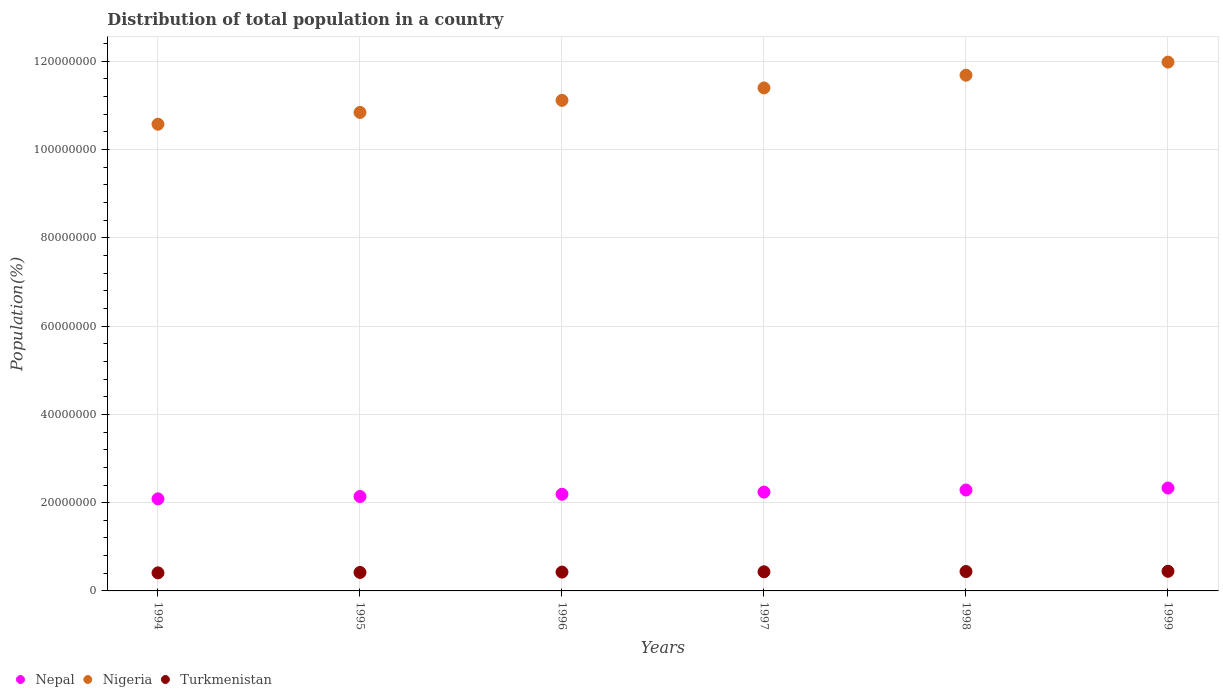How many different coloured dotlines are there?
Provide a short and direct response. 3. Is the number of dotlines equal to the number of legend labels?
Your answer should be very brief. Yes. What is the population of in Nepal in 1994?
Offer a very short reply. 2.09e+07. Across all years, what is the maximum population of in Nigeria?
Provide a succinct answer. 1.20e+08. Across all years, what is the minimum population of in Turkmenistan?
Offer a terse response. 4.10e+06. In which year was the population of in Turkmenistan minimum?
Provide a succinct answer. 1994. What is the total population of in Turkmenistan in the graph?
Offer a very short reply. 2.57e+07. What is the difference between the population of in Nigeria in 1994 and that in 1995?
Make the answer very short. -2.67e+06. What is the difference between the population of in Nigeria in 1994 and the population of in Turkmenistan in 1996?
Offer a very short reply. 1.01e+08. What is the average population of in Turkmenistan per year?
Your answer should be very brief. 4.29e+06. In the year 1995, what is the difference between the population of in Nigeria and population of in Turkmenistan?
Offer a very short reply. 1.04e+08. In how many years, is the population of in Nepal greater than 52000000 %?
Provide a succinct answer. 0. What is the ratio of the population of in Nigeria in 1994 to that in 1995?
Keep it short and to the point. 0.98. Is the population of in Turkmenistan in 1994 less than that in 1995?
Offer a terse response. Yes. What is the difference between the highest and the second highest population of in Nigeria?
Provide a short and direct response. 2.97e+06. What is the difference between the highest and the lowest population of in Nepal?
Your answer should be very brief. 2.46e+06. In how many years, is the population of in Nepal greater than the average population of in Nepal taken over all years?
Keep it short and to the point. 3. Does the population of in Nepal monotonically increase over the years?
Your answer should be very brief. Yes. Is the population of in Turkmenistan strictly greater than the population of in Nepal over the years?
Make the answer very short. No. Is the population of in Nigeria strictly less than the population of in Turkmenistan over the years?
Your answer should be compact. No. How many years are there in the graph?
Your answer should be compact. 6. Does the graph contain any zero values?
Offer a very short reply. No. Where does the legend appear in the graph?
Ensure brevity in your answer.  Bottom left. How many legend labels are there?
Ensure brevity in your answer.  3. How are the legend labels stacked?
Your response must be concise. Horizontal. What is the title of the graph?
Offer a terse response. Distribution of total population in a country. What is the label or title of the Y-axis?
Provide a short and direct response. Population(%). What is the Population(%) in Nepal in 1994?
Provide a succinct answer. 2.09e+07. What is the Population(%) of Nigeria in 1994?
Offer a very short reply. 1.06e+08. What is the Population(%) of Turkmenistan in 1994?
Offer a terse response. 4.10e+06. What is the Population(%) in Nepal in 1995?
Provide a succinct answer. 2.14e+07. What is the Population(%) of Nigeria in 1995?
Provide a short and direct response. 1.08e+08. What is the Population(%) in Turkmenistan in 1995?
Offer a very short reply. 4.19e+06. What is the Population(%) of Nepal in 1996?
Keep it short and to the point. 2.19e+07. What is the Population(%) of Nigeria in 1996?
Offer a very short reply. 1.11e+08. What is the Population(%) of Turkmenistan in 1996?
Offer a terse response. 4.27e+06. What is the Population(%) of Nepal in 1997?
Offer a very short reply. 2.24e+07. What is the Population(%) of Nigeria in 1997?
Provide a short and direct response. 1.14e+08. What is the Population(%) in Turkmenistan in 1997?
Make the answer very short. 4.34e+06. What is the Population(%) of Nepal in 1998?
Offer a terse response. 2.29e+07. What is the Population(%) of Nigeria in 1998?
Your answer should be very brief. 1.17e+08. What is the Population(%) in Turkmenistan in 1998?
Your answer should be compact. 4.40e+06. What is the Population(%) of Nepal in 1999?
Provide a short and direct response. 2.33e+07. What is the Population(%) of Nigeria in 1999?
Your response must be concise. 1.20e+08. What is the Population(%) of Turkmenistan in 1999?
Keep it short and to the point. 4.45e+06. Across all years, what is the maximum Population(%) in Nepal?
Keep it short and to the point. 2.33e+07. Across all years, what is the maximum Population(%) of Nigeria?
Keep it short and to the point. 1.20e+08. Across all years, what is the maximum Population(%) in Turkmenistan?
Give a very brief answer. 4.45e+06. Across all years, what is the minimum Population(%) in Nepal?
Your answer should be very brief. 2.09e+07. Across all years, what is the minimum Population(%) in Nigeria?
Ensure brevity in your answer.  1.06e+08. Across all years, what is the minimum Population(%) of Turkmenistan?
Provide a short and direct response. 4.10e+06. What is the total Population(%) of Nepal in the graph?
Give a very brief answer. 1.33e+08. What is the total Population(%) in Nigeria in the graph?
Your response must be concise. 6.76e+08. What is the total Population(%) of Turkmenistan in the graph?
Ensure brevity in your answer.  2.57e+07. What is the difference between the Population(%) in Nepal in 1994 and that in 1995?
Provide a short and direct response. -5.31e+05. What is the difference between the Population(%) of Nigeria in 1994 and that in 1995?
Make the answer very short. -2.67e+06. What is the difference between the Population(%) in Turkmenistan in 1994 and that in 1995?
Your answer should be very brief. -9.25e+04. What is the difference between the Population(%) in Nepal in 1994 and that in 1996?
Your answer should be compact. -1.04e+06. What is the difference between the Population(%) of Nigeria in 1994 and that in 1996?
Offer a terse response. -5.41e+06. What is the difference between the Population(%) of Turkmenistan in 1994 and that in 1996?
Make the answer very short. -1.72e+05. What is the difference between the Population(%) of Nepal in 1994 and that in 1997?
Ensure brevity in your answer.  -1.54e+06. What is the difference between the Population(%) in Nigeria in 1994 and that in 1997?
Your answer should be very brief. -8.22e+06. What is the difference between the Population(%) in Turkmenistan in 1994 and that in 1997?
Ensure brevity in your answer.  -2.40e+05. What is the difference between the Population(%) of Nepal in 1994 and that in 1998?
Make the answer very short. -2.01e+06. What is the difference between the Population(%) in Nigeria in 1994 and that in 1998?
Your response must be concise. -1.11e+07. What is the difference between the Population(%) of Turkmenistan in 1994 and that in 1998?
Provide a short and direct response. -3.00e+05. What is the difference between the Population(%) of Nepal in 1994 and that in 1999?
Offer a terse response. -2.46e+06. What is the difference between the Population(%) of Nigeria in 1994 and that in 1999?
Your response must be concise. -1.41e+07. What is the difference between the Population(%) of Turkmenistan in 1994 and that in 1999?
Your response must be concise. -3.54e+05. What is the difference between the Population(%) in Nepal in 1995 and that in 1996?
Your response must be concise. -5.12e+05. What is the difference between the Population(%) of Nigeria in 1995 and that in 1996?
Give a very brief answer. -2.74e+06. What is the difference between the Population(%) of Turkmenistan in 1995 and that in 1996?
Offer a terse response. -7.97e+04. What is the difference between the Population(%) in Nepal in 1995 and that in 1997?
Ensure brevity in your answer.  -1.00e+06. What is the difference between the Population(%) in Nigeria in 1995 and that in 1997?
Offer a terse response. -5.55e+06. What is the difference between the Population(%) of Turkmenistan in 1995 and that in 1997?
Offer a very short reply. -1.48e+05. What is the difference between the Population(%) of Nepal in 1995 and that in 1998?
Ensure brevity in your answer.  -1.48e+06. What is the difference between the Population(%) in Nigeria in 1995 and that in 1998?
Your answer should be very brief. -8.44e+06. What is the difference between the Population(%) of Turkmenistan in 1995 and that in 1998?
Give a very brief answer. -2.07e+05. What is the difference between the Population(%) in Nepal in 1995 and that in 1999?
Offer a terse response. -1.92e+06. What is the difference between the Population(%) in Nigeria in 1995 and that in 1999?
Give a very brief answer. -1.14e+07. What is the difference between the Population(%) of Turkmenistan in 1995 and that in 1999?
Keep it short and to the point. -2.61e+05. What is the difference between the Population(%) in Nepal in 1996 and that in 1997?
Give a very brief answer. -4.93e+05. What is the difference between the Population(%) in Nigeria in 1996 and that in 1997?
Give a very brief answer. -2.81e+06. What is the difference between the Population(%) of Turkmenistan in 1996 and that in 1997?
Offer a terse response. -6.83e+04. What is the difference between the Population(%) of Nepal in 1996 and that in 1998?
Offer a very short reply. -9.64e+05. What is the difference between the Population(%) in Nigeria in 1996 and that in 1998?
Keep it short and to the point. -5.70e+06. What is the difference between the Population(%) of Turkmenistan in 1996 and that in 1998?
Offer a terse response. -1.28e+05. What is the difference between the Population(%) in Nepal in 1996 and that in 1999?
Your answer should be compact. -1.41e+06. What is the difference between the Population(%) in Nigeria in 1996 and that in 1999?
Make the answer very short. -8.66e+06. What is the difference between the Population(%) of Turkmenistan in 1996 and that in 1999?
Provide a short and direct response. -1.82e+05. What is the difference between the Population(%) of Nepal in 1997 and that in 1998?
Give a very brief answer. -4.71e+05. What is the difference between the Population(%) in Nigeria in 1997 and that in 1998?
Your answer should be compact. -2.89e+06. What is the difference between the Population(%) in Turkmenistan in 1997 and that in 1998?
Offer a very short reply. -5.93e+04. What is the difference between the Population(%) in Nepal in 1997 and that in 1999?
Your answer should be very brief. -9.20e+05. What is the difference between the Population(%) of Nigeria in 1997 and that in 1999?
Your answer should be very brief. -5.85e+06. What is the difference between the Population(%) of Turkmenistan in 1997 and that in 1999?
Offer a terse response. -1.13e+05. What is the difference between the Population(%) in Nepal in 1998 and that in 1999?
Give a very brief answer. -4.49e+05. What is the difference between the Population(%) in Nigeria in 1998 and that in 1999?
Make the answer very short. -2.97e+06. What is the difference between the Population(%) of Turkmenistan in 1998 and that in 1999?
Keep it short and to the point. -5.41e+04. What is the difference between the Population(%) of Nepal in 1994 and the Population(%) of Nigeria in 1995?
Offer a terse response. -8.76e+07. What is the difference between the Population(%) of Nepal in 1994 and the Population(%) of Turkmenistan in 1995?
Make the answer very short. 1.67e+07. What is the difference between the Population(%) in Nigeria in 1994 and the Population(%) in Turkmenistan in 1995?
Keep it short and to the point. 1.02e+08. What is the difference between the Population(%) of Nepal in 1994 and the Population(%) of Nigeria in 1996?
Ensure brevity in your answer.  -9.03e+07. What is the difference between the Population(%) in Nepal in 1994 and the Population(%) in Turkmenistan in 1996?
Provide a succinct answer. 1.66e+07. What is the difference between the Population(%) of Nigeria in 1994 and the Population(%) of Turkmenistan in 1996?
Your response must be concise. 1.01e+08. What is the difference between the Population(%) in Nepal in 1994 and the Population(%) in Nigeria in 1997?
Offer a very short reply. -9.31e+07. What is the difference between the Population(%) of Nepal in 1994 and the Population(%) of Turkmenistan in 1997?
Your response must be concise. 1.65e+07. What is the difference between the Population(%) in Nigeria in 1994 and the Population(%) in Turkmenistan in 1997?
Your answer should be very brief. 1.01e+08. What is the difference between the Population(%) in Nepal in 1994 and the Population(%) in Nigeria in 1998?
Your response must be concise. -9.60e+07. What is the difference between the Population(%) of Nepal in 1994 and the Population(%) of Turkmenistan in 1998?
Ensure brevity in your answer.  1.65e+07. What is the difference between the Population(%) in Nigeria in 1994 and the Population(%) in Turkmenistan in 1998?
Ensure brevity in your answer.  1.01e+08. What is the difference between the Population(%) in Nepal in 1994 and the Population(%) in Nigeria in 1999?
Provide a succinct answer. -9.90e+07. What is the difference between the Population(%) of Nepal in 1994 and the Population(%) of Turkmenistan in 1999?
Offer a very short reply. 1.64e+07. What is the difference between the Population(%) of Nigeria in 1994 and the Population(%) of Turkmenistan in 1999?
Provide a succinct answer. 1.01e+08. What is the difference between the Population(%) of Nepal in 1995 and the Population(%) of Nigeria in 1996?
Offer a very short reply. -8.98e+07. What is the difference between the Population(%) of Nepal in 1995 and the Population(%) of Turkmenistan in 1996?
Provide a short and direct response. 1.71e+07. What is the difference between the Population(%) of Nigeria in 1995 and the Population(%) of Turkmenistan in 1996?
Ensure brevity in your answer.  1.04e+08. What is the difference between the Population(%) in Nepal in 1995 and the Population(%) in Nigeria in 1997?
Provide a succinct answer. -9.26e+07. What is the difference between the Population(%) in Nepal in 1995 and the Population(%) in Turkmenistan in 1997?
Provide a short and direct response. 1.71e+07. What is the difference between the Population(%) in Nigeria in 1995 and the Population(%) in Turkmenistan in 1997?
Keep it short and to the point. 1.04e+08. What is the difference between the Population(%) in Nepal in 1995 and the Population(%) in Nigeria in 1998?
Keep it short and to the point. -9.55e+07. What is the difference between the Population(%) of Nepal in 1995 and the Population(%) of Turkmenistan in 1998?
Offer a very short reply. 1.70e+07. What is the difference between the Population(%) in Nigeria in 1995 and the Population(%) in Turkmenistan in 1998?
Make the answer very short. 1.04e+08. What is the difference between the Population(%) of Nepal in 1995 and the Population(%) of Nigeria in 1999?
Give a very brief answer. -9.84e+07. What is the difference between the Population(%) of Nepal in 1995 and the Population(%) of Turkmenistan in 1999?
Your response must be concise. 1.69e+07. What is the difference between the Population(%) in Nigeria in 1995 and the Population(%) in Turkmenistan in 1999?
Make the answer very short. 1.04e+08. What is the difference between the Population(%) of Nepal in 1996 and the Population(%) of Nigeria in 1997?
Your answer should be very brief. -9.21e+07. What is the difference between the Population(%) in Nepal in 1996 and the Population(%) in Turkmenistan in 1997?
Give a very brief answer. 1.76e+07. What is the difference between the Population(%) of Nigeria in 1996 and the Population(%) of Turkmenistan in 1997?
Your response must be concise. 1.07e+08. What is the difference between the Population(%) in Nepal in 1996 and the Population(%) in Nigeria in 1998?
Provide a short and direct response. -9.50e+07. What is the difference between the Population(%) in Nepal in 1996 and the Population(%) in Turkmenistan in 1998?
Your response must be concise. 1.75e+07. What is the difference between the Population(%) in Nigeria in 1996 and the Population(%) in Turkmenistan in 1998?
Provide a succinct answer. 1.07e+08. What is the difference between the Population(%) of Nepal in 1996 and the Population(%) of Nigeria in 1999?
Ensure brevity in your answer.  -9.79e+07. What is the difference between the Population(%) of Nepal in 1996 and the Population(%) of Turkmenistan in 1999?
Provide a succinct answer. 1.75e+07. What is the difference between the Population(%) of Nigeria in 1996 and the Population(%) of Turkmenistan in 1999?
Your answer should be compact. 1.07e+08. What is the difference between the Population(%) of Nepal in 1997 and the Population(%) of Nigeria in 1998?
Offer a terse response. -9.45e+07. What is the difference between the Population(%) in Nepal in 1997 and the Population(%) in Turkmenistan in 1998?
Offer a terse response. 1.80e+07. What is the difference between the Population(%) of Nigeria in 1997 and the Population(%) of Turkmenistan in 1998?
Your answer should be very brief. 1.10e+08. What is the difference between the Population(%) of Nepal in 1997 and the Population(%) of Nigeria in 1999?
Your answer should be very brief. -9.74e+07. What is the difference between the Population(%) of Nepal in 1997 and the Population(%) of Turkmenistan in 1999?
Ensure brevity in your answer.  1.79e+07. What is the difference between the Population(%) in Nigeria in 1997 and the Population(%) in Turkmenistan in 1999?
Give a very brief answer. 1.10e+08. What is the difference between the Population(%) in Nepal in 1998 and the Population(%) in Nigeria in 1999?
Give a very brief answer. -9.70e+07. What is the difference between the Population(%) in Nepal in 1998 and the Population(%) in Turkmenistan in 1999?
Offer a very short reply. 1.84e+07. What is the difference between the Population(%) in Nigeria in 1998 and the Population(%) in Turkmenistan in 1999?
Make the answer very short. 1.12e+08. What is the average Population(%) of Nepal per year?
Give a very brief answer. 2.21e+07. What is the average Population(%) in Nigeria per year?
Your response must be concise. 1.13e+08. What is the average Population(%) of Turkmenistan per year?
Ensure brevity in your answer.  4.29e+06. In the year 1994, what is the difference between the Population(%) in Nepal and Population(%) in Nigeria?
Keep it short and to the point. -8.49e+07. In the year 1994, what is the difference between the Population(%) of Nepal and Population(%) of Turkmenistan?
Your answer should be very brief. 1.68e+07. In the year 1994, what is the difference between the Population(%) in Nigeria and Population(%) in Turkmenistan?
Offer a very short reply. 1.02e+08. In the year 1995, what is the difference between the Population(%) of Nepal and Population(%) of Nigeria?
Give a very brief answer. -8.70e+07. In the year 1995, what is the difference between the Population(%) in Nepal and Population(%) in Turkmenistan?
Make the answer very short. 1.72e+07. In the year 1995, what is the difference between the Population(%) in Nigeria and Population(%) in Turkmenistan?
Ensure brevity in your answer.  1.04e+08. In the year 1996, what is the difference between the Population(%) of Nepal and Population(%) of Nigeria?
Your answer should be very brief. -8.93e+07. In the year 1996, what is the difference between the Population(%) of Nepal and Population(%) of Turkmenistan?
Offer a terse response. 1.76e+07. In the year 1996, what is the difference between the Population(%) of Nigeria and Population(%) of Turkmenistan?
Provide a short and direct response. 1.07e+08. In the year 1997, what is the difference between the Population(%) of Nepal and Population(%) of Nigeria?
Provide a succinct answer. -9.16e+07. In the year 1997, what is the difference between the Population(%) of Nepal and Population(%) of Turkmenistan?
Offer a very short reply. 1.81e+07. In the year 1997, what is the difference between the Population(%) of Nigeria and Population(%) of Turkmenistan?
Keep it short and to the point. 1.10e+08. In the year 1998, what is the difference between the Population(%) in Nepal and Population(%) in Nigeria?
Your answer should be compact. -9.40e+07. In the year 1998, what is the difference between the Population(%) of Nepal and Population(%) of Turkmenistan?
Give a very brief answer. 1.85e+07. In the year 1998, what is the difference between the Population(%) in Nigeria and Population(%) in Turkmenistan?
Make the answer very short. 1.12e+08. In the year 1999, what is the difference between the Population(%) of Nepal and Population(%) of Nigeria?
Your answer should be very brief. -9.65e+07. In the year 1999, what is the difference between the Population(%) of Nepal and Population(%) of Turkmenistan?
Provide a succinct answer. 1.89e+07. In the year 1999, what is the difference between the Population(%) of Nigeria and Population(%) of Turkmenistan?
Offer a very short reply. 1.15e+08. What is the ratio of the Population(%) in Nepal in 1994 to that in 1995?
Offer a very short reply. 0.98. What is the ratio of the Population(%) in Nigeria in 1994 to that in 1995?
Offer a very short reply. 0.98. What is the ratio of the Population(%) in Turkmenistan in 1994 to that in 1995?
Make the answer very short. 0.98. What is the ratio of the Population(%) of Nepal in 1994 to that in 1996?
Offer a very short reply. 0.95. What is the ratio of the Population(%) of Nigeria in 1994 to that in 1996?
Ensure brevity in your answer.  0.95. What is the ratio of the Population(%) of Turkmenistan in 1994 to that in 1996?
Your response must be concise. 0.96. What is the ratio of the Population(%) in Nepal in 1994 to that in 1997?
Ensure brevity in your answer.  0.93. What is the ratio of the Population(%) of Nigeria in 1994 to that in 1997?
Provide a short and direct response. 0.93. What is the ratio of the Population(%) of Turkmenistan in 1994 to that in 1997?
Your answer should be compact. 0.94. What is the ratio of the Population(%) of Nepal in 1994 to that in 1998?
Ensure brevity in your answer.  0.91. What is the ratio of the Population(%) in Nigeria in 1994 to that in 1998?
Keep it short and to the point. 0.91. What is the ratio of the Population(%) in Turkmenistan in 1994 to that in 1998?
Provide a short and direct response. 0.93. What is the ratio of the Population(%) of Nepal in 1994 to that in 1999?
Provide a succinct answer. 0.89. What is the ratio of the Population(%) of Nigeria in 1994 to that in 1999?
Provide a short and direct response. 0.88. What is the ratio of the Population(%) in Turkmenistan in 1994 to that in 1999?
Provide a succinct answer. 0.92. What is the ratio of the Population(%) in Nepal in 1995 to that in 1996?
Your answer should be compact. 0.98. What is the ratio of the Population(%) of Nigeria in 1995 to that in 1996?
Your answer should be compact. 0.98. What is the ratio of the Population(%) in Turkmenistan in 1995 to that in 1996?
Make the answer very short. 0.98. What is the ratio of the Population(%) of Nepal in 1995 to that in 1997?
Keep it short and to the point. 0.96. What is the ratio of the Population(%) in Nigeria in 1995 to that in 1997?
Ensure brevity in your answer.  0.95. What is the ratio of the Population(%) of Turkmenistan in 1995 to that in 1997?
Offer a very short reply. 0.97. What is the ratio of the Population(%) of Nepal in 1995 to that in 1998?
Make the answer very short. 0.94. What is the ratio of the Population(%) of Nigeria in 1995 to that in 1998?
Your response must be concise. 0.93. What is the ratio of the Population(%) of Turkmenistan in 1995 to that in 1998?
Provide a short and direct response. 0.95. What is the ratio of the Population(%) of Nepal in 1995 to that in 1999?
Provide a short and direct response. 0.92. What is the ratio of the Population(%) of Nigeria in 1995 to that in 1999?
Provide a short and direct response. 0.9. What is the ratio of the Population(%) in Nepal in 1996 to that in 1997?
Your answer should be very brief. 0.98. What is the ratio of the Population(%) of Nigeria in 1996 to that in 1997?
Keep it short and to the point. 0.98. What is the ratio of the Population(%) of Turkmenistan in 1996 to that in 1997?
Give a very brief answer. 0.98. What is the ratio of the Population(%) in Nepal in 1996 to that in 1998?
Provide a succinct answer. 0.96. What is the ratio of the Population(%) of Nigeria in 1996 to that in 1998?
Your response must be concise. 0.95. What is the ratio of the Population(%) in Turkmenistan in 1996 to that in 1998?
Offer a terse response. 0.97. What is the ratio of the Population(%) in Nepal in 1996 to that in 1999?
Your response must be concise. 0.94. What is the ratio of the Population(%) of Nigeria in 1996 to that in 1999?
Your answer should be very brief. 0.93. What is the ratio of the Population(%) of Turkmenistan in 1996 to that in 1999?
Ensure brevity in your answer.  0.96. What is the ratio of the Population(%) in Nepal in 1997 to that in 1998?
Your answer should be compact. 0.98. What is the ratio of the Population(%) of Nigeria in 1997 to that in 1998?
Ensure brevity in your answer.  0.98. What is the ratio of the Population(%) of Turkmenistan in 1997 to that in 1998?
Provide a succinct answer. 0.99. What is the ratio of the Population(%) in Nepal in 1997 to that in 1999?
Your answer should be compact. 0.96. What is the ratio of the Population(%) of Nigeria in 1997 to that in 1999?
Make the answer very short. 0.95. What is the ratio of the Population(%) in Turkmenistan in 1997 to that in 1999?
Offer a very short reply. 0.97. What is the ratio of the Population(%) of Nepal in 1998 to that in 1999?
Give a very brief answer. 0.98. What is the ratio of the Population(%) of Nigeria in 1998 to that in 1999?
Make the answer very short. 0.98. What is the difference between the highest and the second highest Population(%) in Nepal?
Your answer should be compact. 4.49e+05. What is the difference between the highest and the second highest Population(%) in Nigeria?
Your response must be concise. 2.97e+06. What is the difference between the highest and the second highest Population(%) in Turkmenistan?
Provide a succinct answer. 5.41e+04. What is the difference between the highest and the lowest Population(%) in Nepal?
Give a very brief answer. 2.46e+06. What is the difference between the highest and the lowest Population(%) of Nigeria?
Offer a very short reply. 1.41e+07. What is the difference between the highest and the lowest Population(%) of Turkmenistan?
Your response must be concise. 3.54e+05. 